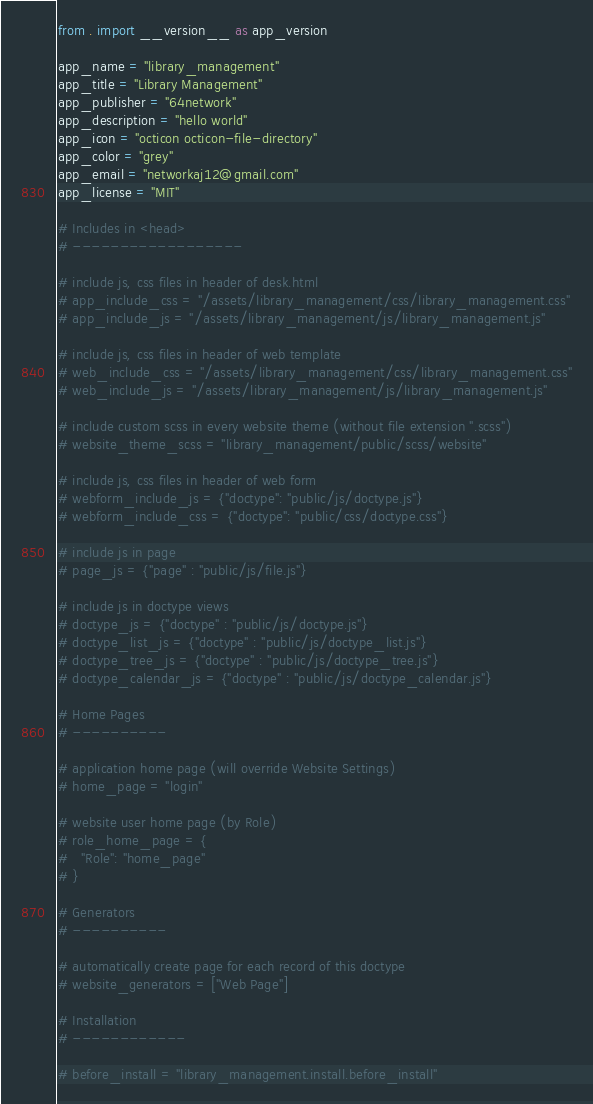Convert code to text. <code><loc_0><loc_0><loc_500><loc_500><_Python_>from . import __version__ as app_version

app_name = "library_management"
app_title = "Library Management"
app_publisher = "64network"
app_description = "hello world"
app_icon = "octicon octicon-file-directory"
app_color = "grey"
app_email = "networkaj12@gmail.com"
app_license = "MIT"

# Includes in <head>
# ------------------

# include js, css files in header of desk.html
# app_include_css = "/assets/library_management/css/library_management.css"
# app_include_js = "/assets/library_management/js/library_management.js"

# include js, css files in header of web template
# web_include_css = "/assets/library_management/css/library_management.css"
# web_include_js = "/assets/library_management/js/library_management.js"

# include custom scss in every website theme (without file extension ".scss")
# website_theme_scss = "library_management/public/scss/website"

# include js, css files in header of web form
# webform_include_js = {"doctype": "public/js/doctype.js"}
# webform_include_css = {"doctype": "public/css/doctype.css"}

# include js in page
# page_js = {"page" : "public/js/file.js"}

# include js in doctype views
# doctype_js = {"doctype" : "public/js/doctype.js"}
# doctype_list_js = {"doctype" : "public/js/doctype_list.js"}
# doctype_tree_js = {"doctype" : "public/js/doctype_tree.js"}
# doctype_calendar_js = {"doctype" : "public/js/doctype_calendar.js"}

# Home Pages
# ----------

# application home page (will override Website Settings)
# home_page = "login"

# website user home page (by Role)
# role_home_page = {
#	"Role": "home_page"
# }

# Generators
# ----------

# automatically create page for each record of this doctype
# website_generators = ["Web Page"]

# Installation
# ------------

# before_install = "library_management.install.before_install"</code> 